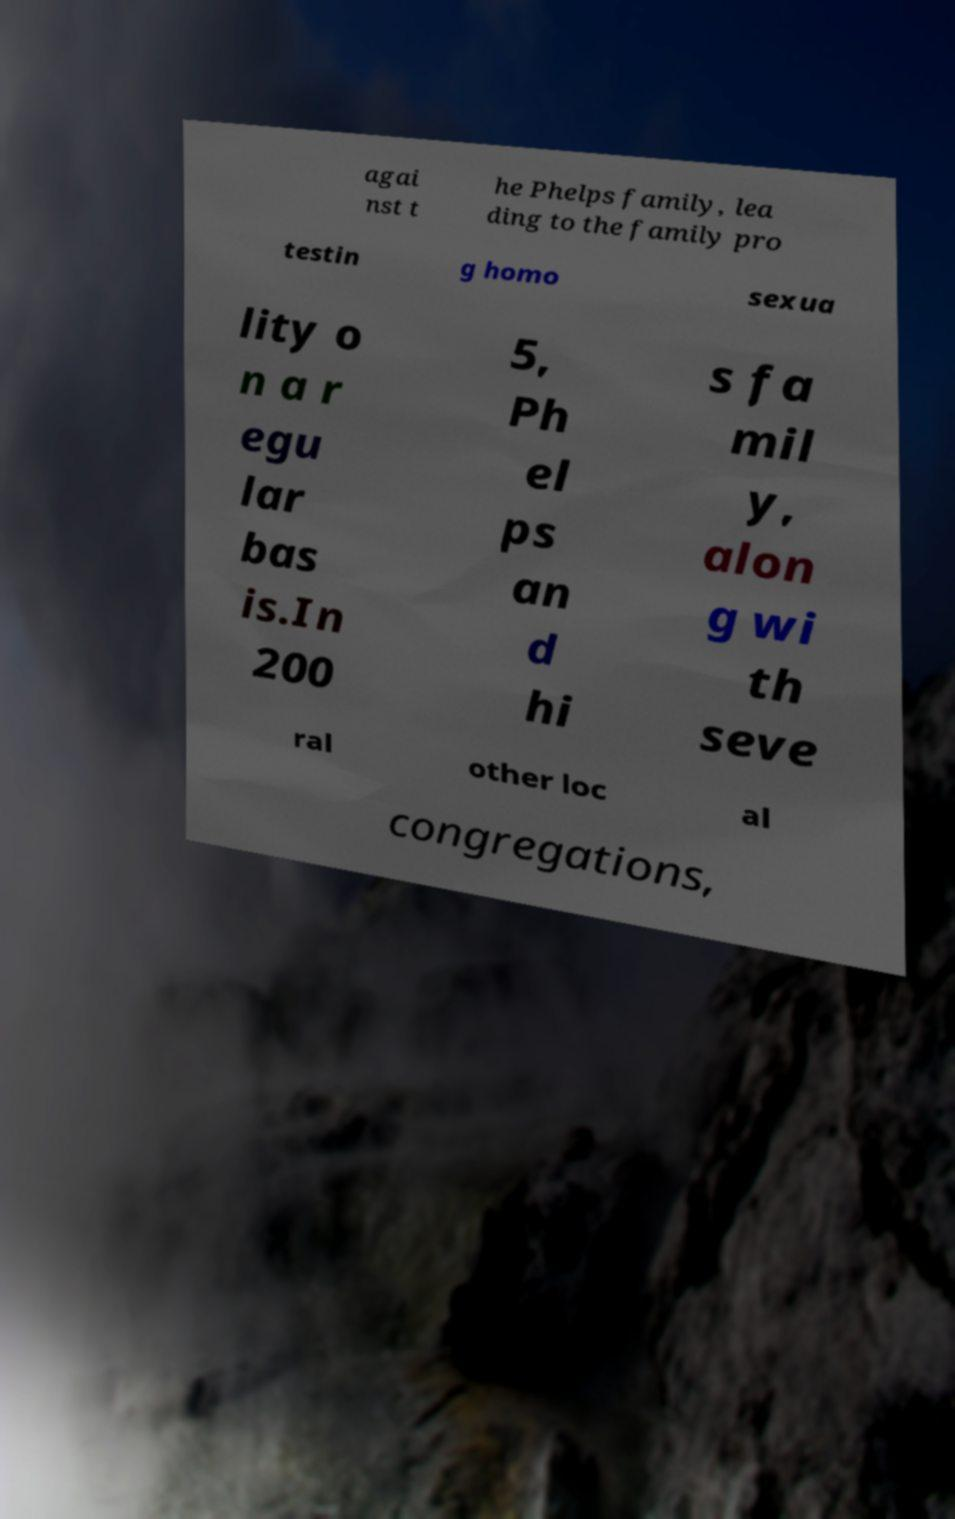Please identify and transcribe the text found in this image. agai nst t he Phelps family, lea ding to the family pro testin g homo sexua lity o n a r egu lar bas is.In 200 5, Ph el ps an d hi s fa mil y, alon g wi th seve ral other loc al congregations, 